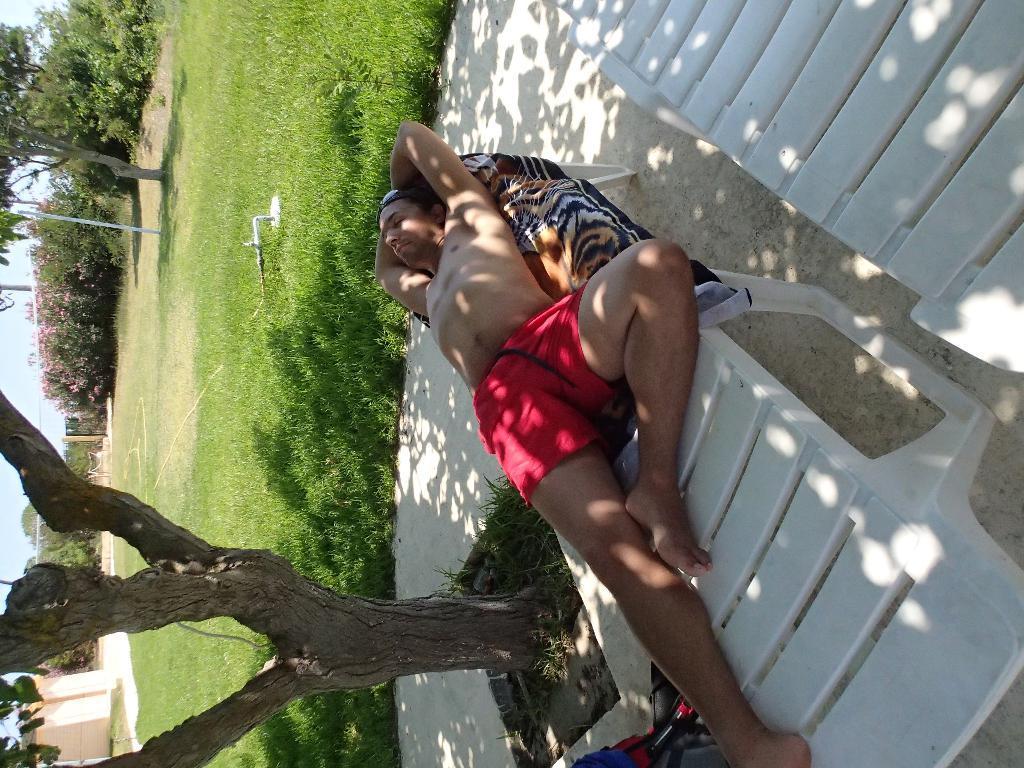Describe this image in one or two sentences. In this image we can see a person with red shorts is lying on a bench. To the left side of the image we can see a tree. In the background, we can see group of plants, poles, building and the sky. 